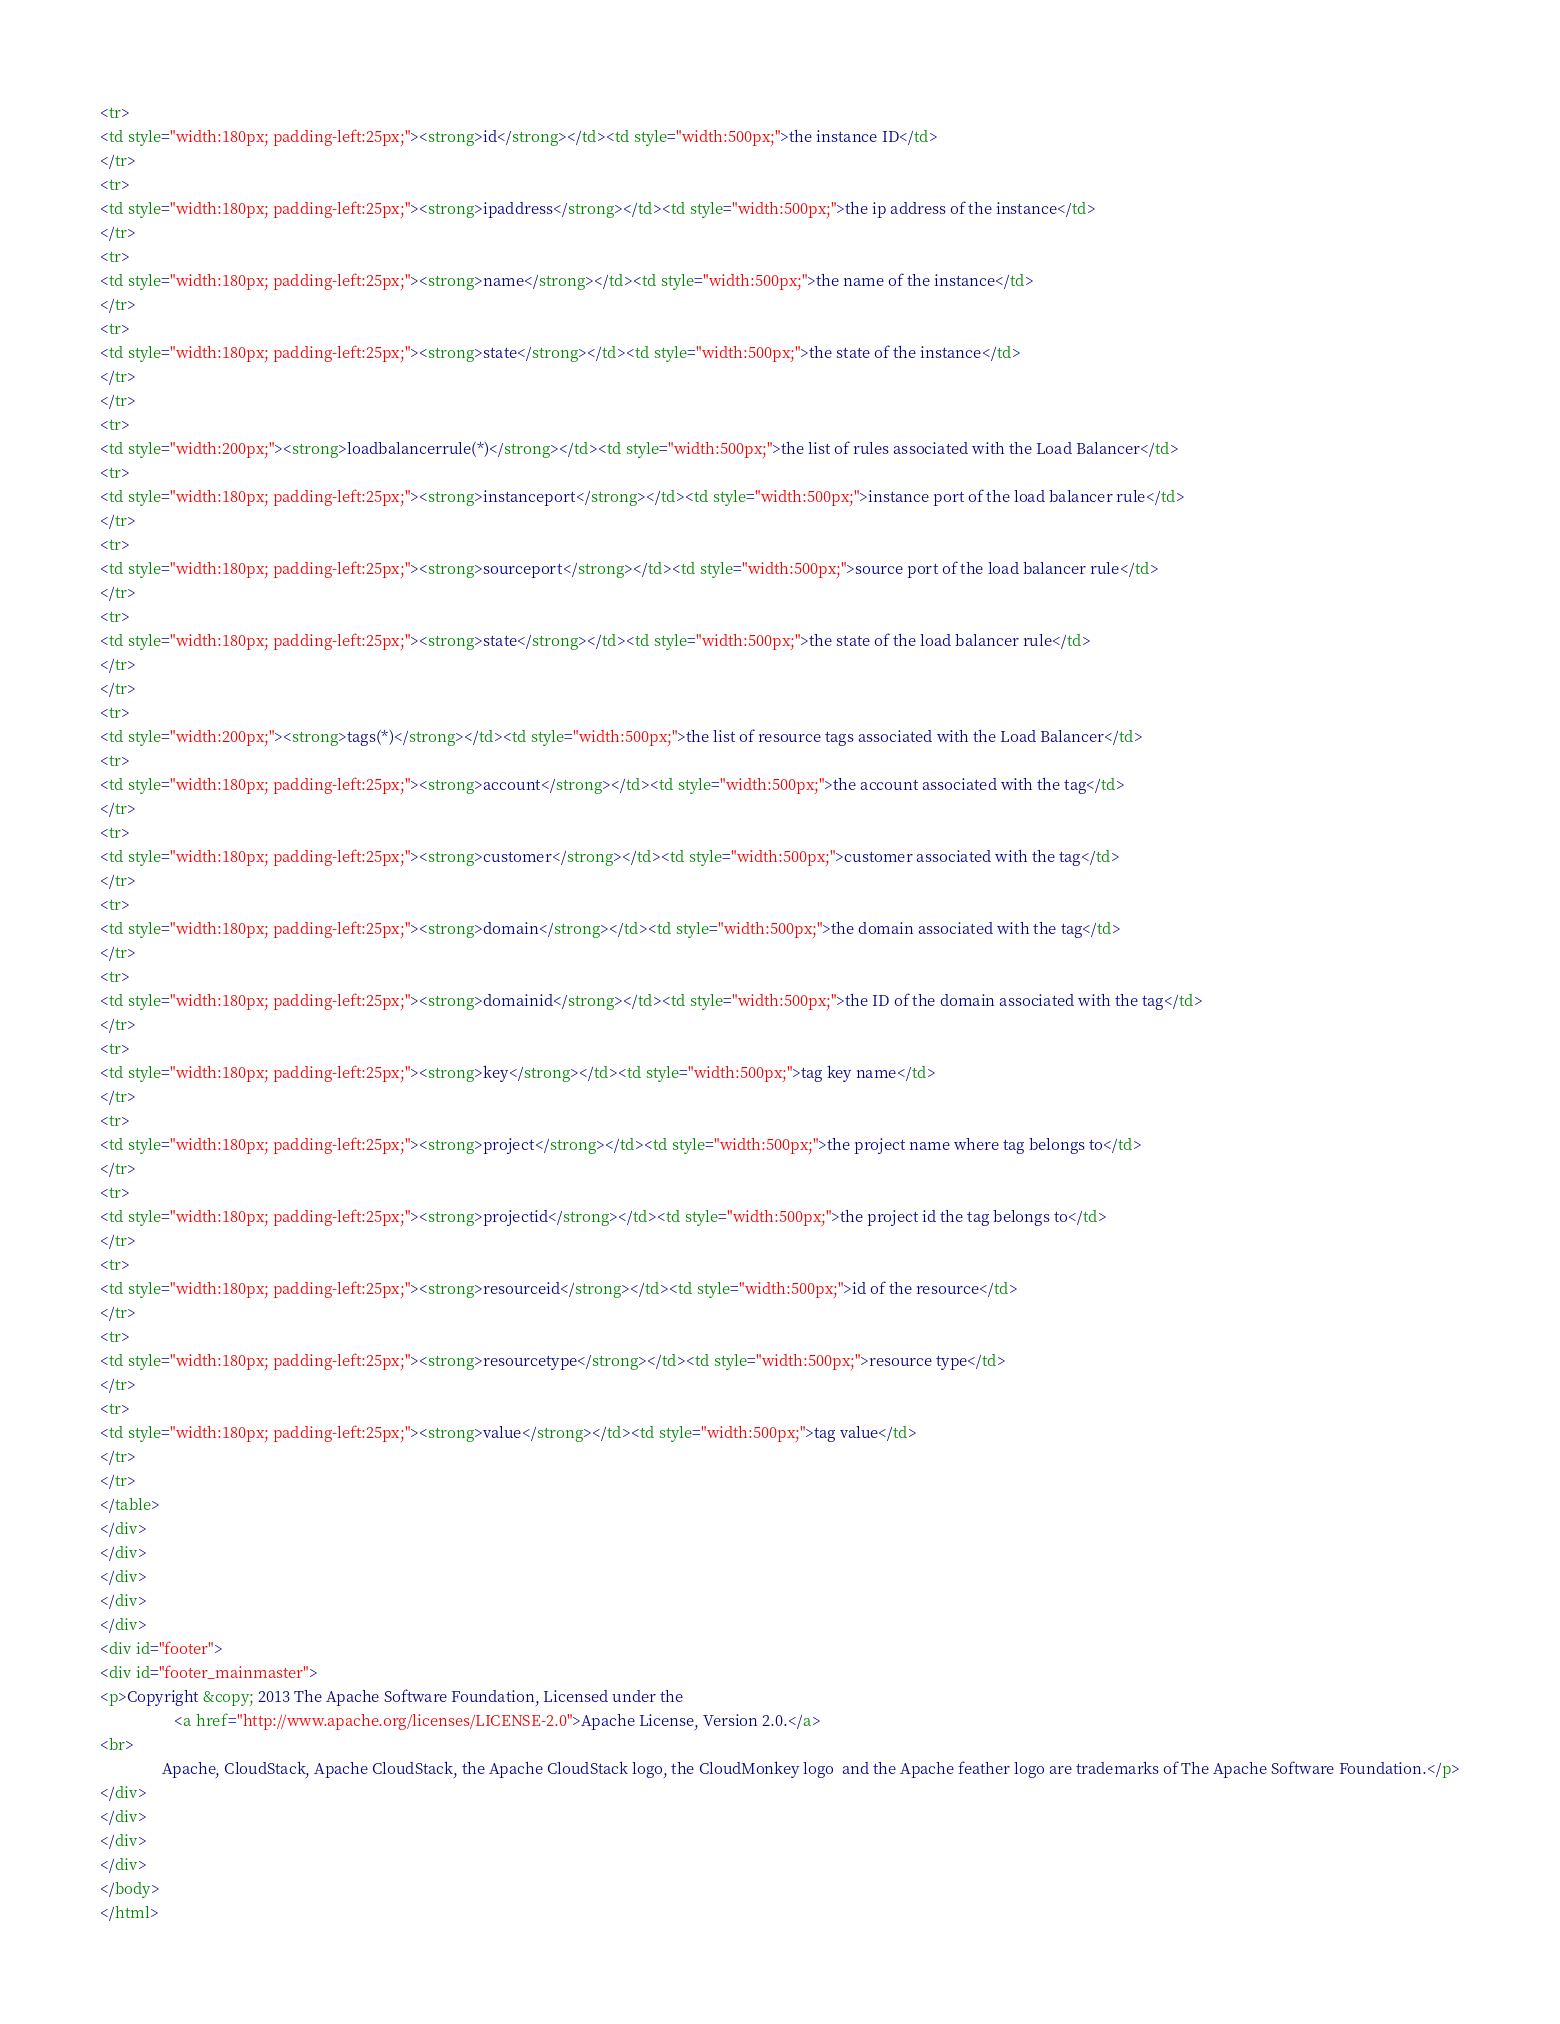<code> <loc_0><loc_0><loc_500><loc_500><_HTML_><tr>
<td style="width:180px; padding-left:25px;"><strong>id</strong></td><td style="width:500px;">the instance ID</td>
</tr>
<tr>
<td style="width:180px; padding-left:25px;"><strong>ipaddress</strong></td><td style="width:500px;">the ip address of the instance</td>
</tr>
<tr>
<td style="width:180px; padding-left:25px;"><strong>name</strong></td><td style="width:500px;">the name of the instance</td>
</tr>
<tr>
<td style="width:180px; padding-left:25px;"><strong>state</strong></td><td style="width:500px;">the state of the instance</td>
</tr>
</tr>
<tr>
<td style="width:200px;"><strong>loadbalancerrule(*)</strong></td><td style="width:500px;">the list of rules associated with the Load Balancer</td>
<tr>
<td style="width:180px; padding-left:25px;"><strong>instanceport</strong></td><td style="width:500px;">instance port of the load balancer rule</td>
</tr>
<tr>
<td style="width:180px; padding-left:25px;"><strong>sourceport</strong></td><td style="width:500px;">source port of the load balancer rule</td>
</tr>
<tr>
<td style="width:180px; padding-left:25px;"><strong>state</strong></td><td style="width:500px;">the state of the load balancer rule</td>
</tr>
</tr>
<tr>
<td style="width:200px;"><strong>tags(*)</strong></td><td style="width:500px;">the list of resource tags associated with the Load Balancer</td>
<tr>
<td style="width:180px; padding-left:25px;"><strong>account</strong></td><td style="width:500px;">the account associated with the tag</td>
</tr>
<tr>
<td style="width:180px; padding-left:25px;"><strong>customer</strong></td><td style="width:500px;">customer associated with the tag</td>
</tr>
<tr>
<td style="width:180px; padding-left:25px;"><strong>domain</strong></td><td style="width:500px;">the domain associated with the tag</td>
</tr>
<tr>
<td style="width:180px; padding-left:25px;"><strong>domainid</strong></td><td style="width:500px;">the ID of the domain associated with the tag</td>
</tr>
<tr>
<td style="width:180px; padding-left:25px;"><strong>key</strong></td><td style="width:500px;">tag key name</td>
</tr>
<tr>
<td style="width:180px; padding-left:25px;"><strong>project</strong></td><td style="width:500px;">the project name where tag belongs to</td>
</tr>
<tr>
<td style="width:180px; padding-left:25px;"><strong>projectid</strong></td><td style="width:500px;">the project id the tag belongs to</td>
</tr>
<tr>
<td style="width:180px; padding-left:25px;"><strong>resourceid</strong></td><td style="width:500px;">id of the resource</td>
</tr>
<tr>
<td style="width:180px; padding-left:25px;"><strong>resourcetype</strong></td><td style="width:500px;">resource type</td>
</tr>
<tr>
<td style="width:180px; padding-left:25px;"><strong>value</strong></td><td style="width:500px;">tag value</td>
</tr>
</tr>
</table>
</div>
</div>
</div>
</div>
</div>
<div id="footer">
<div id="footer_mainmaster">
<p>Copyright &copy; 2013 The Apache Software Foundation, Licensed under the
                   <a href="http://www.apache.org/licenses/LICENSE-2.0">Apache License, Version 2.0.</a>
<br>
                Apache, CloudStack, Apache CloudStack, the Apache CloudStack logo, the CloudMonkey logo  and the Apache feather logo are trademarks of The Apache Software Foundation.</p>
</div>
</div>
</div>
</div>
</body>
</html>
</code> 